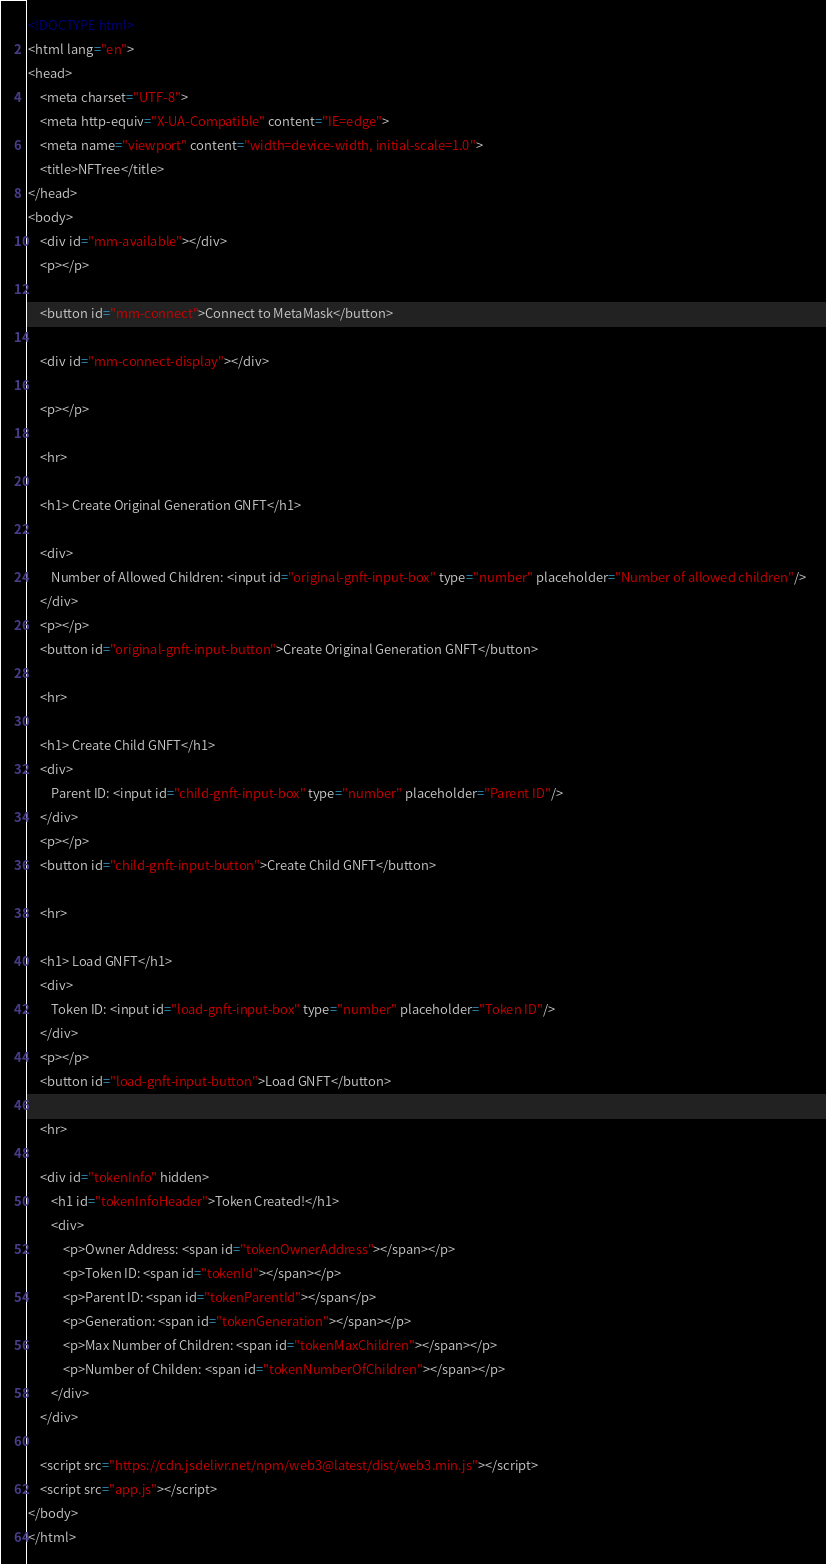<code> <loc_0><loc_0><loc_500><loc_500><_HTML_><!DOCTYPE html>
<html lang="en">
<head>
    <meta charset="UTF-8">
    <meta http-equiv="X-UA-Compatible" content="IE=edge">
    <meta name="viewport" content="width=device-width, initial-scale=1.0">
    <title>NFTree</title>
</head>
<body>
    <div id="mm-available"></div>
    <p></p>

    <button id="mm-connect">Connect to MetaMask</button>

    <div id="mm-connect-display"></div>

    <p></p>

    <hr>

    <h1> Create Original Generation GNFT</h1>

    <div>
        Number of Allowed Children: <input id="original-gnft-input-box" type="number" placeholder="Number of allowed children"/>  
    </div>
    <p></p>
    <button id="original-gnft-input-button">Create Original Generation GNFT</button>

    <hr>

    <h1> Create Child GNFT</h1>
    <div>
        Parent ID: <input id="child-gnft-input-box" type="number" placeholder="Parent ID"/>  
    </div>
    <p></p>
    <button id="child-gnft-input-button">Create Child GNFT</button>

    <hr>

    <h1> Load GNFT</h1>
    <div>
        Token ID: <input id="load-gnft-input-box" type="number" placeholder="Token ID"/>
    </div>
    <p></p>
    <button id="load-gnft-input-button">Load GNFT</button>

    <hr>

    <div id="tokenInfo" hidden>
        <h1 id="tokenInfoHeader">Token Created!</h1>
        <div>
            <p>Owner Address: <span id="tokenOwnerAddress"></span></p>
            <p>Token ID: <span id="tokenId"></span></p>
            <p>Parent ID: <span id="tokenParentId"></span</p>
            <p>Generation: <span id="tokenGeneration"></span></p>
            <p>Max Number of Children: <span id="tokenMaxChildren"></span></p>
            <p>Number of Childen: <span id="tokenNumberOfChildren"></span></p>
        </div>
    </div>

    <script src="https://cdn.jsdelivr.net/npm/web3@latest/dist/web3.min.js"></script>
    <script src="app.js"></script>
</body>
</html></code> 